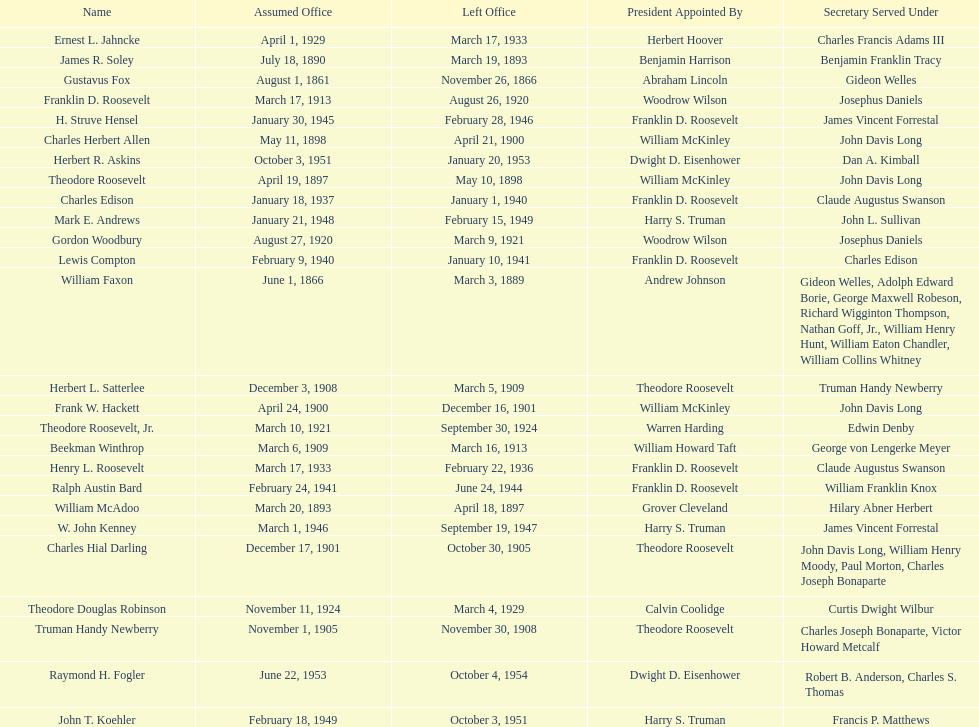When did raymond h. fogler leave the office of assistant secretary of the navy? October 4, 1954. 